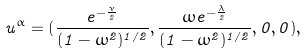<formula> <loc_0><loc_0><loc_500><loc_500>u ^ { \alpha } = ( \frac { e ^ { - \frac { \nu } { 2 } } } { ( 1 - \omega ^ { 2 } ) ^ { 1 / 2 } } , \frac { \omega e ^ { - \frac { \lambda } { 2 } } } { ( 1 - \omega ^ { 2 } ) ^ { 1 / 2 } } , 0 , 0 ) ,</formula> 